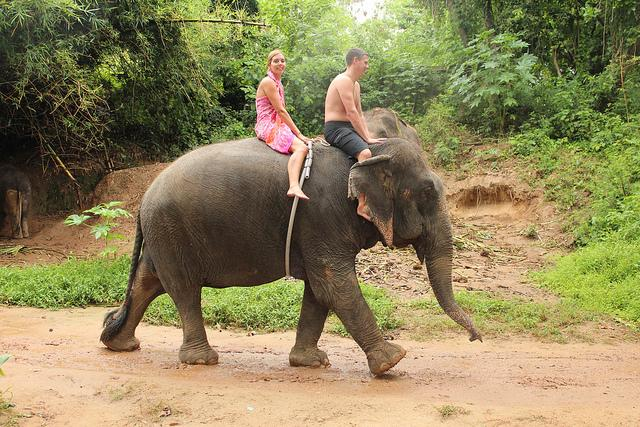What is the slowest thing that can move faster than the large thing here? Please explain your reasoning. horse. Horses can't move as quickly and nimbly as ants, cars or planes. 